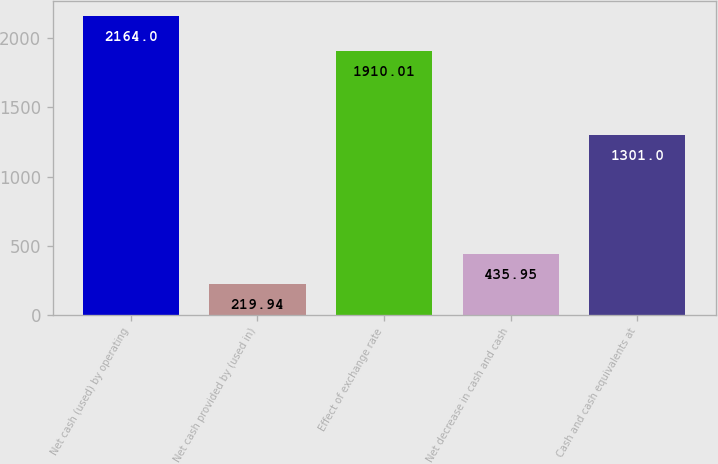Convert chart to OTSL. <chart><loc_0><loc_0><loc_500><loc_500><bar_chart><fcel>Net cash (used) by operating<fcel>Net cash provided by (used in)<fcel>Effect of exchange rate<fcel>Net decrease in cash and cash<fcel>Cash and cash equivalents at<nl><fcel>2164<fcel>219.94<fcel>1910.01<fcel>435.95<fcel>1301<nl></chart> 